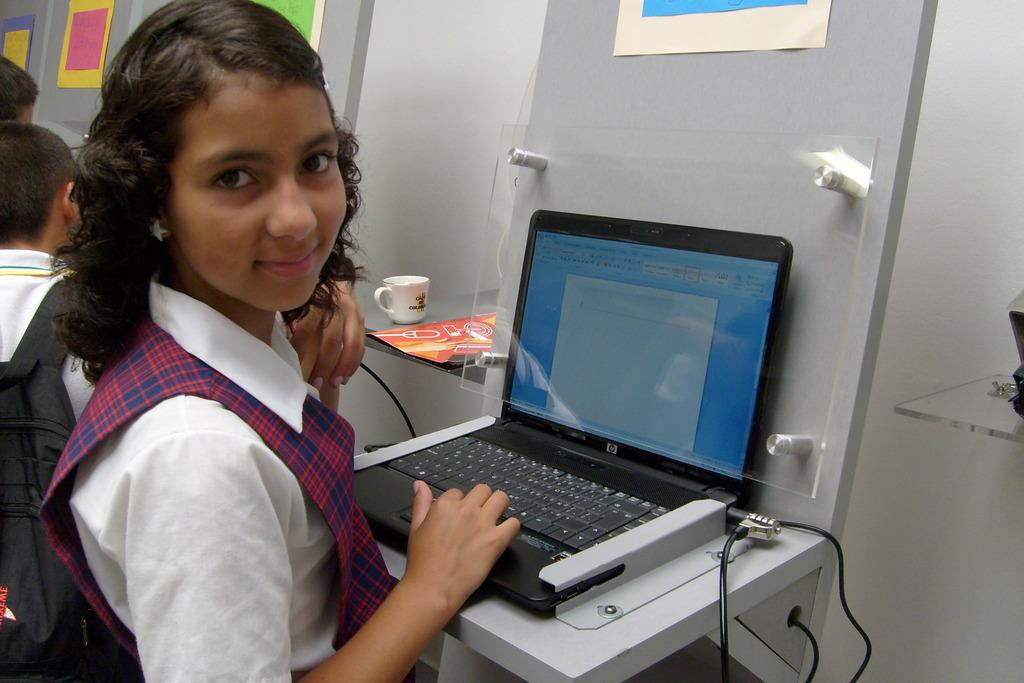<image>
Create a compact narrative representing the image presented. A young girl in a uniform sits in front of an HP laptop 